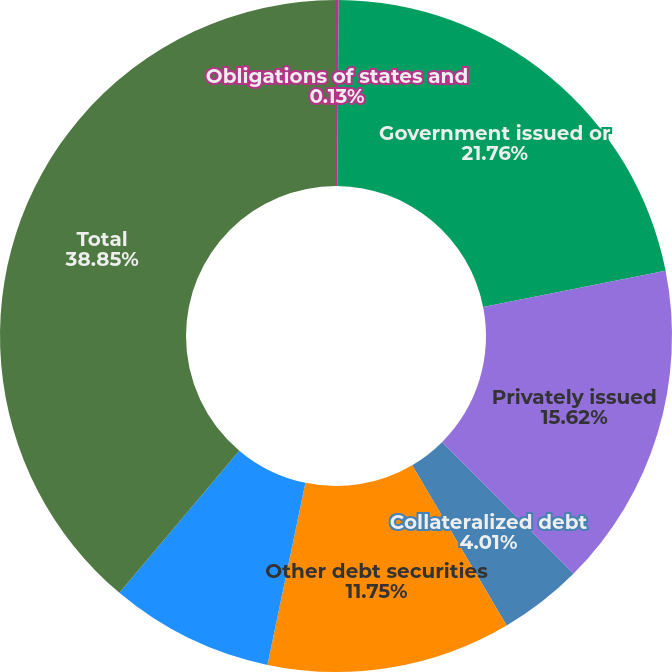Convert chart to OTSL. <chart><loc_0><loc_0><loc_500><loc_500><pie_chart><fcel>Obligations of states and<fcel>Government issued or<fcel>Privately issued<fcel>Collateralized debt<fcel>Other debt securities<fcel>Equity securities<fcel>Total<nl><fcel>0.13%<fcel>21.76%<fcel>15.62%<fcel>4.01%<fcel>11.75%<fcel>7.88%<fcel>38.85%<nl></chart> 